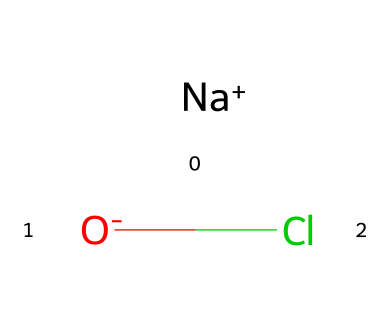What is the primary element in this chemical structure? The chemical structure contains chlorine (Cl) as the base element involved in its reactive nature as a disinfectant.
Answer: chlorine How many atoms are present in this chemical composition? The structure includes a sodium atom (Na), an oxygen atom (O), and a chlorine atom (Cl), totaling three atoms.
Answer: three What type of bond is primarily present in this chemical? The chemical features ionic bonding as indicated by the presence of the charged sodium ion (Na+) and chloride ion (Cl-), which form an ionic compound.
Answer: ionic What properties make chlorine-based disinfectants effective? Chlorine compounds possess strong oxidizing properties and can disrupt microbial cell membranes, making them effective disinfectants for conservation.
Answer: oxidizing properties How does the presence of sodium in this chemical affect its properties? Sodium serves as a counterion balancing the charge of the chloride, which aids in solubility and stability in solution, enhancing the effectiveness of the disinfectant.
Answer: solubility What type of chemical is represented by the chlorine component in this disinfectant? The chlorine component can be classified as a halogen, which is known for its high reactivity and use in disinfectants.
Answer: halogen 